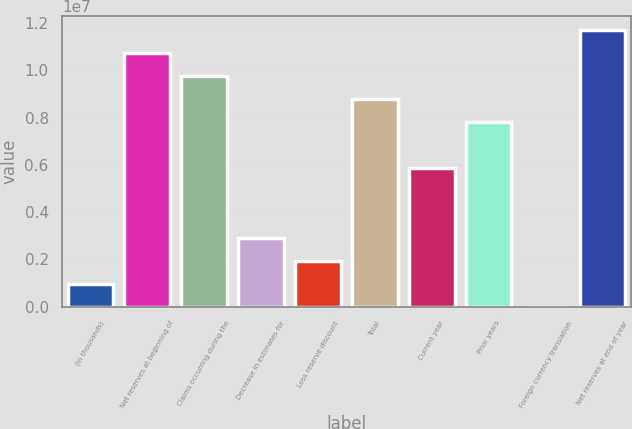Convert chart. <chart><loc_0><loc_0><loc_500><loc_500><bar_chart><fcel>(In thousands)<fcel>Net reserves at beginning of<fcel>Claims occurring during the<fcel>Decrease in estimates for<fcel>Loss reserve discount<fcel>Total<fcel>Current year<fcel>Prior years<fcel>Foreign currency translation<fcel>Net reserves at end of year<nl><fcel>975284<fcel>1.07262e+07<fcel>9.75109e+06<fcel>2.92546e+06<fcel>1.95037e+06<fcel>8.776e+06<fcel>5.85073e+06<fcel>7.80091e+06<fcel>195<fcel>1.17013e+07<nl></chart> 